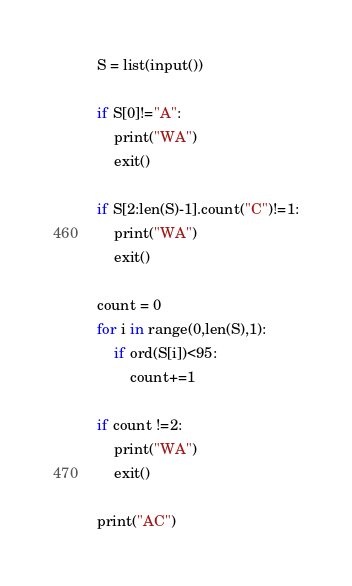Convert code to text. <code><loc_0><loc_0><loc_500><loc_500><_Python_>S = list(input())

if S[0]!="A":
    print("WA")
    exit()

if S[2:len(S)-1].count("C")!=1:
    print("WA")
    exit()

count = 0
for i in range(0,len(S),1):
    if ord(S[i])<95:
        count+=1

if count !=2:
    print("WA")
    exit()

print("AC")</code> 